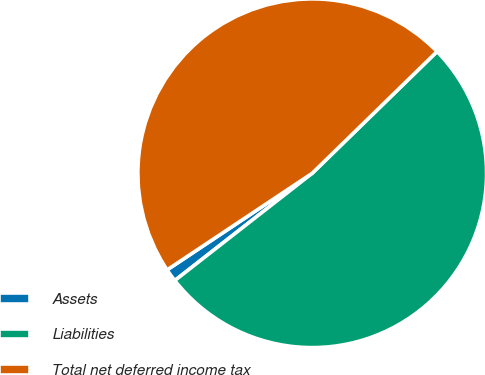Convert chart to OTSL. <chart><loc_0><loc_0><loc_500><loc_500><pie_chart><fcel>Assets<fcel>Liabilities<fcel>Total net deferred income tax<nl><fcel>1.2%<fcel>51.75%<fcel>47.05%<nl></chart> 